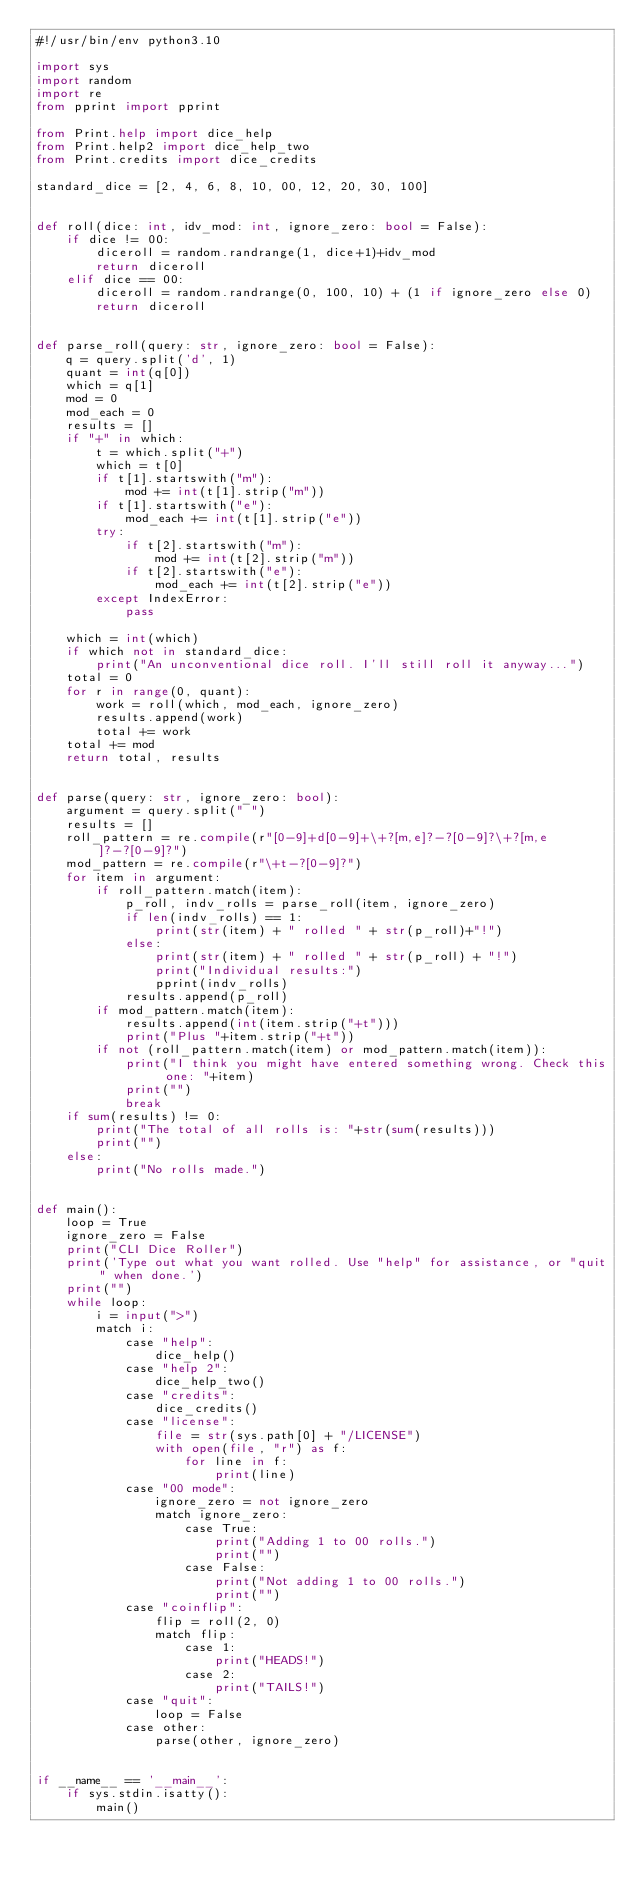<code> <loc_0><loc_0><loc_500><loc_500><_Python_>#!/usr/bin/env python3.10

import sys
import random
import re
from pprint import pprint

from Print.help import dice_help
from Print.help2 import dice_help_two
from Print.credits import dice_credits

standard_dice = [2, 4, 6, 8, 10, 00, 12, 20, 30, 100]


def roll(dice: int, idv_mod: int, ignore_zero: bool = False):
    if dice != 00:
        diceroll = random.randrange(1, dice+1)+idv_mod
        return diceroll
    elif dice == 00:
        diceroll = random.randrange(0, 100, 10) + (1 if ignore_zero else 0)
        return diceroll


def parse_roll(query: str, ignore_zero: bool = False):
    q = query.split('d', 1)
    quant = int(q[0])
    which = q[1]
    mod = 0
    mod_each = 0
    results = []
    if "+" in which:
        t = which.split("+")
        which = t[0]
        if t[1].startswith("m"):
            mod += int(t[1].strip("m"))
        if t[1].startswith("e"):
            mod_each += int(t[1].strip("e"))
        try:
            if t[2].startswith("m"):
                mod += int(t[2].strip("m"))
            if t[2].startswith("e"):
                mod_each += int(t[2].strip("e"))
        except IndexError:
            pass

    which = int(which)
    if which not in standard_dice:
        print("An unconventional dice roll. I'll still roll it anyway...")
    total = 0
    for r in range(0, quant):
        work = roll(which, mod_each, ignore_zero)
        results.append(work)
        total += work
    total += mod
    return total, results


def parse(query: str, ignore_zero: bool):
    argument = query.split(" ")
    results = []
    roll_pattern = re.compile(r"[0-9]+d[0-9]+\+?[m,e]?-?[0-9]?\+?[m,e]?-?[0-9]?")
    mod_pattern = re.compile(r"\+t-?[0-9]?")
    for item in argument:
        if roll_pattern.match(item):
            p_roll, indv_rolls = parse_roll(item, ignore_zero)
            if len(indv_rolls) == 1:
                print(str(item) + " rolled " + str(p_roll)+"!")
            else:
                print(str(item) + " rolled " + str(p_roll) + "!")
                print("Individual results:")
                pprint(indv_rolls)
            results.append(p_roll)
        if mod_pattern.match(item):
            results.append(int(item.strip("+t")))
            print("Plus "+item.strip("+t"))
        if not (roll_pattern.match(item) or mod_pattern.match(item)):
            print("I think you might have entered something wrong. Check this one: "+item)
            print("")
            break
    if sum(results) != 0:
        print("The total of all rolls is: "+str(sum(results)))
        print("")
    else:
        print("No rolls made.")


def main():
    loop = True
    ignore_zero = False
    print("CLI Dice Roller")
    print('Type out what you want rolled. Use "help" for assistance, or "quit" when done.')
    print("")
    while loop:
        i = input(">")
        match i:
            case "help":
                dice_help()
            case "help 2":
                dice_help_two()
            case "credits":
                dice_credits()
            case "license":
                file = str(sys.path[0] + "/LICENSE")
                with open(file, "r") as f:
                    for line in f:
                        print(line)
            case "00 mode":
                ignore_zero = not ignore_zero
                match ignore_zero:
                    case True:
                        print("Adding 1 to 00 rolls.")
                        print("")
                    case False:
                        print("Not adding 1 to 00 rolls.")
                        print("")
            case "coinflip":
                flip = roll(2, 0)
                match flip:
                    case 1:
                        print("HEADS!")
                    case 2:
                        print("TAILS!")
            case "quit":
                loop = False
            case other:
                parse(other, ignore_zero)


if __name__ == '__main__':
    if sys.stdin.isatty():
        main()
</code> 